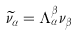Convert formula to latex. <formula><loc_0><loc_0><loc_500><loc_500>\widetilde { \nu } _ { \alpha } = \Lambda ^ { \beta } _ { \alpha } \nu _ { \beta }</formula> 